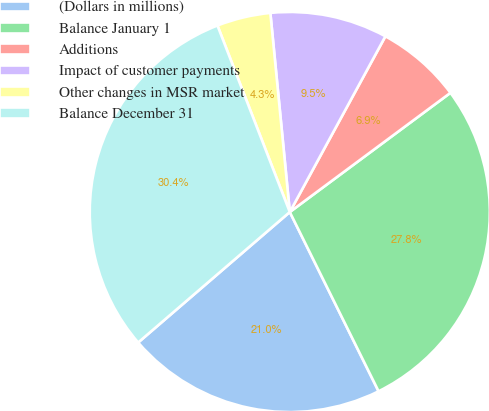Convert chart to OTSL. <chart><loc_0><loc_0><loc_500><loc_500><pie_chart><fcel>(Dollars in millions)<fcel>Balance January 1<fcel>Additions<fcel>Impact of customer payments<fcel>Other changes in MSR market<fcel>Balance December 31<nl><fcel>21.01%<fcel>27.84%<fcel>6.91%<fcel>9.48%<fcel>4.34%<fcel>30.42%<nl></chart> 